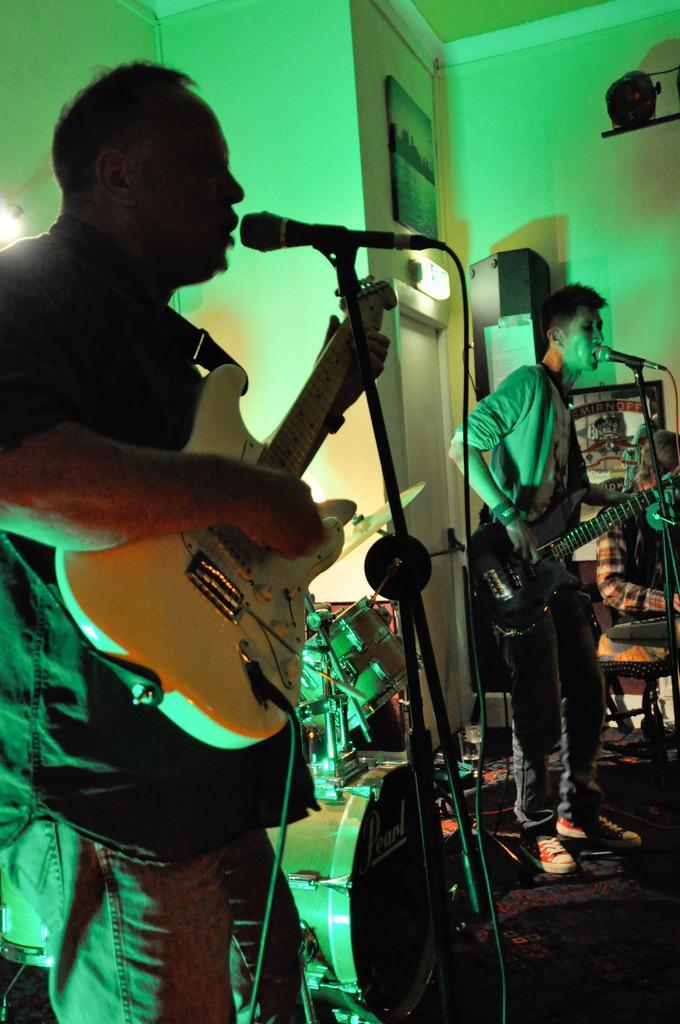Could you give a brief overview of what you see in this image? This 2 persons are playing guitar and singing in-front of mic. These are musical instruments. A picture on wall. 